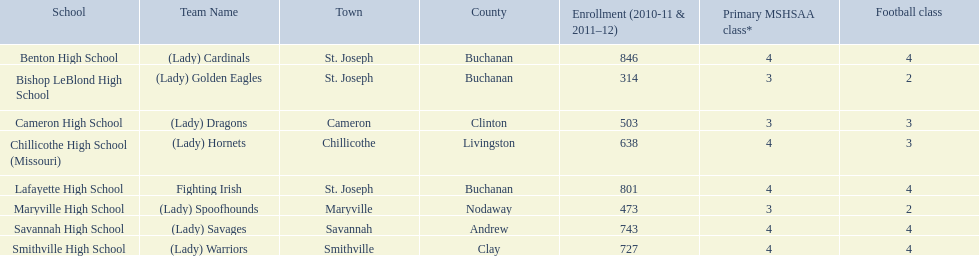What is the total student enrollment at each educational institution? Benton High School, 846, Bishop LeBlond High School, 314, Cameron High School, 503, Chillicothe High School (Missouri), 638, Lafayette High School, 801, Maryville High School, 473, Savannah High School, 743, Smithville High School, 727. Which school offers exactly three football classes? Cameron High School, 3, Chillicothe High School (Missouri), 3. Which school has a student population of 638 and provides three football courses? Chillicothe High School (Missouri). 